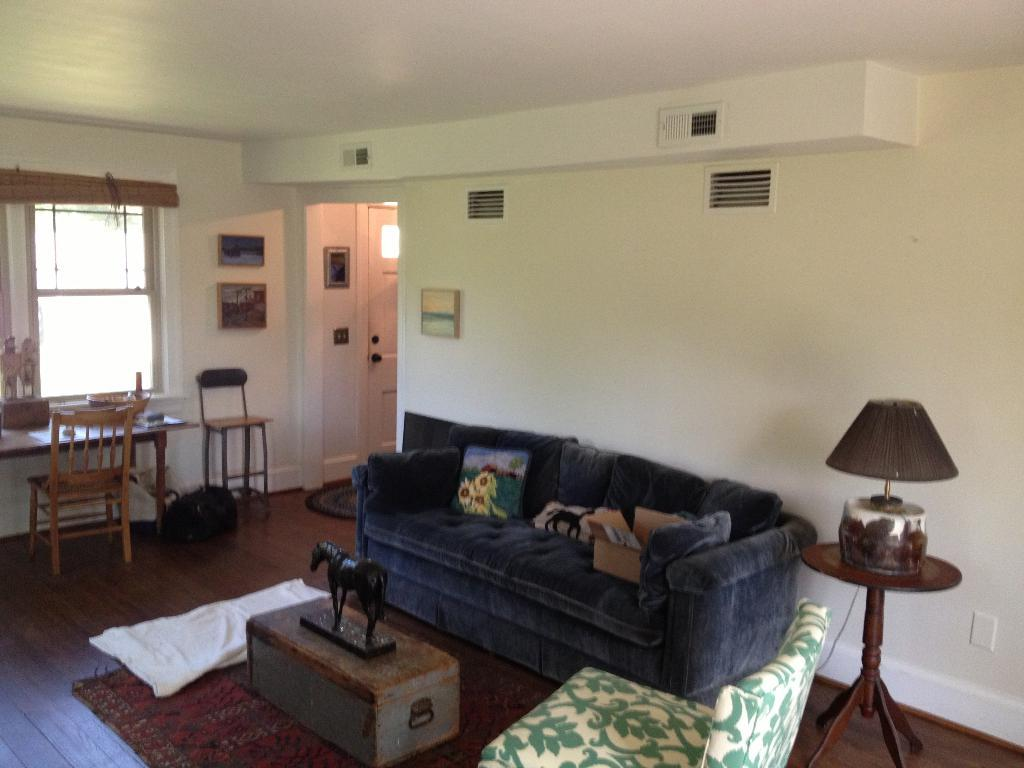What type of furniture is in the room? There is a sofa and a dining table in the room. What type of lighting is present in the room? There is a lamp in the room. What decorative item can be seen on a table in the room? There is a horse sculpture on a table in the room. What type of prose is being recited by the man in the room? There is no man present in the room, and no prose is being recited. How does the horse sculpture smash the dining table in the room? The horse sculpture does not smash the dining table; it is a stationary decorative item. 